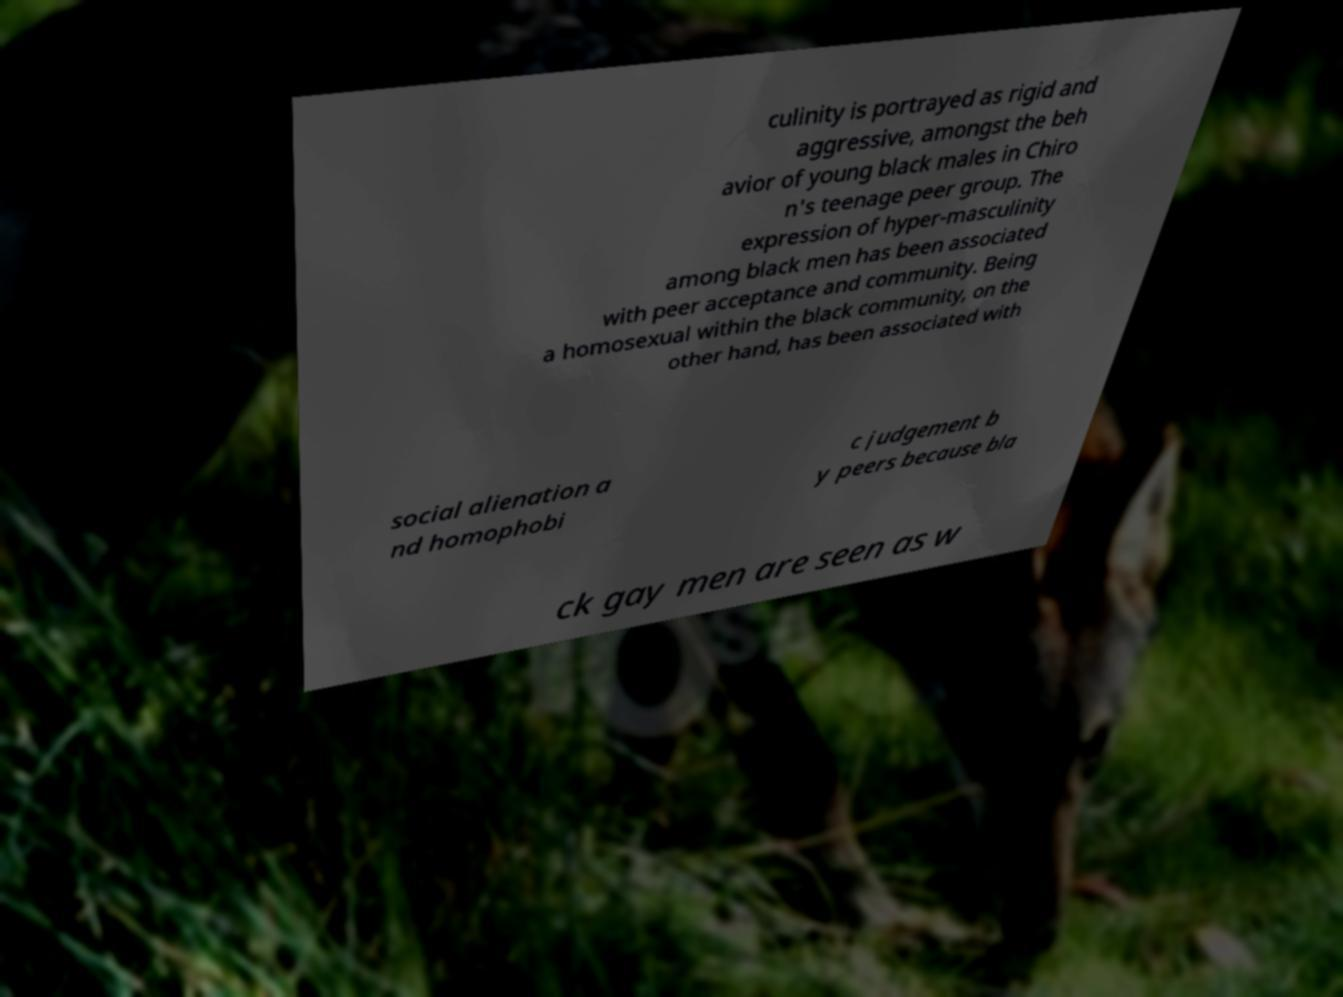Could you extract and type out the text from this image? culinity is portrayed as rigid and aggressive, amongst the beh avior of young black males in Chiro n's teenage peer group. The expression of hyper-masculinity among black men has been associated with peer acceptance and community. Being a homosexual within the black community, on the other hand, has been associated with social alienation a nd homophobi c judgement b y peers because bla ck gay men are seen as w 